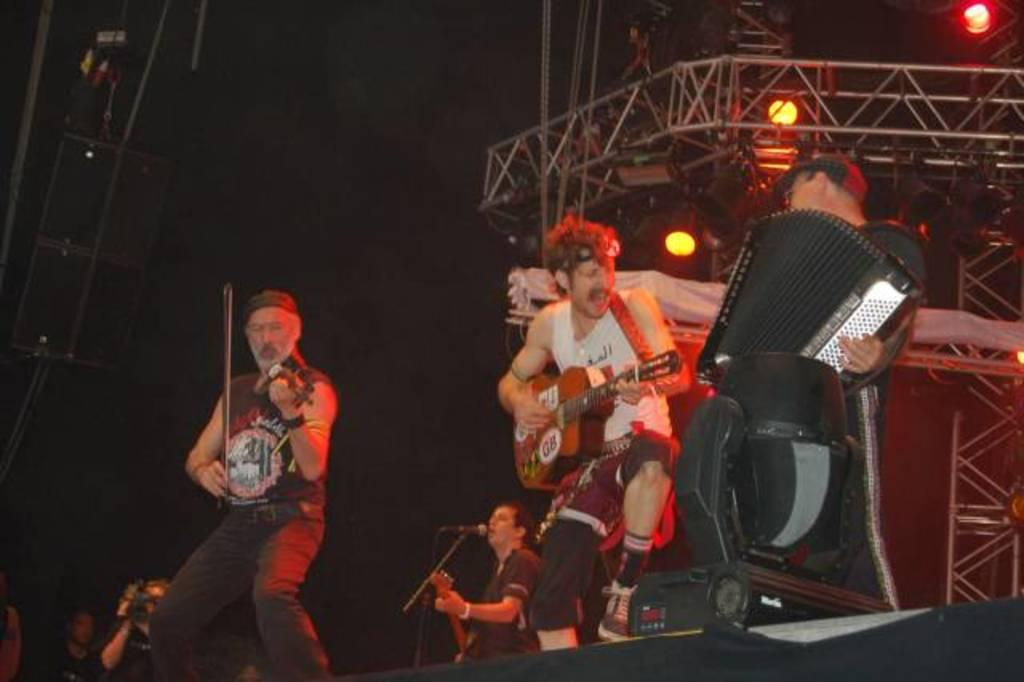What are the people in the image doing? The people in the image are playing musical instruments. What object is in front of the people? There is a microphone in front of the people. What can be seen in the background of the image? There is a frame and lights visible in the background. What type of fruit is being attacked by a cork in the image? There is no fruit or cork present in the image. 